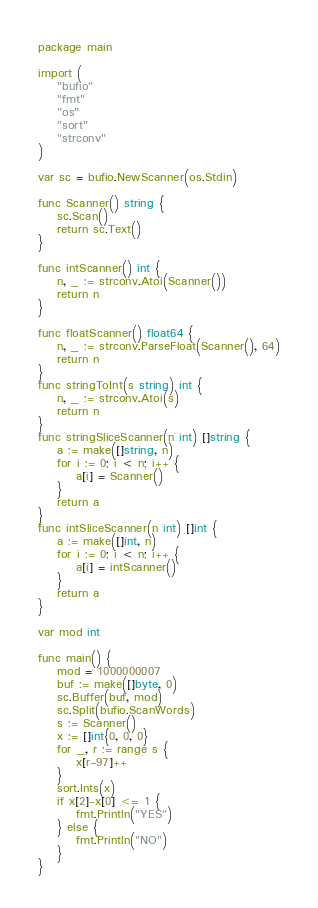<code> <loc_0><loc_0><loc_500><loc_500><_Go_>package main

import (
	"bufio"
	"fmt"
	"os"
	"sort"
	"strconv"
)

var sc = bufio.NewScanner(os.Stdin)

func Scanner() string {
	sc.Scan()
	return sc.Text()
}

func intScanner() int {
	n, _ := strconv.Atoi(Scanner())
	return n
}

func floatScanner() float64 {
	n, _ := strconv.ParseFloat(Scanner(), 64)
	return n
}
func stringToInt(s string) int {
	n, _ := strconv.Atoi(s)
	return n
}
func stringSliceScanner(n int) []string {
	a := make([]string, n)
	for i := 0; i < n; i++ {
		a[i] = Scanner()
	}
	return a
}
func intSliceScanner(n int) []int {
	a := make([]int, n)
	for i := 0; i < n; i++ {
		a[i] = intScanner()
	}
	return a
}

var mod int

func main() {
	mod = 1000000007
	buf := make([]byte, 0)
	sc.Buffer(buf, mod)
	sc.Split(bufio.ScanWords)
	s := Scanner()
	x := []int{0, 0, 0}
	for _, r := range s {
		x[r-97]++
	}
	sort.Ints(x)
	if x[2]-x[0] <= 1 {
		fmt.Println("YES")
	} else {
		fmt.Println("NO")
	}
}
</code> 